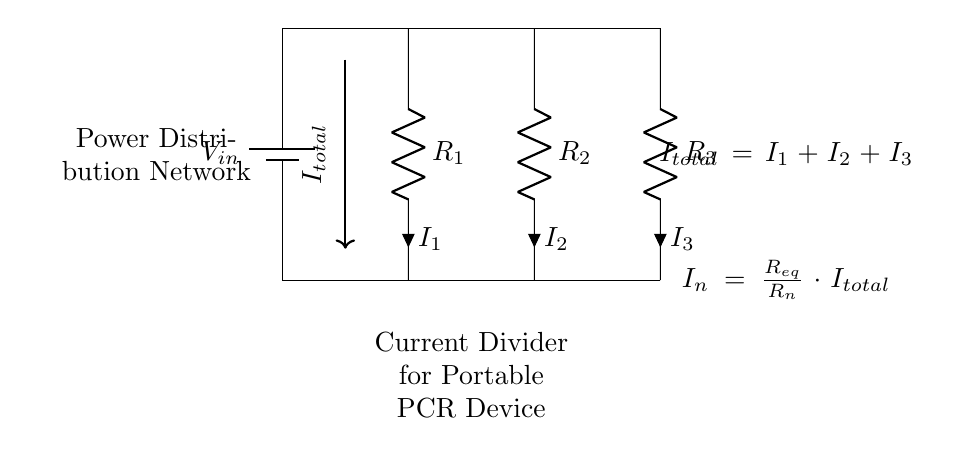What is the input voltage of this circuit? The input voltage, indicated by the label V_in, is the voltage source connected at the top of the circuit. While the specific value is not provided in the diagram, it is represented as V_in.
Answer: V_in What are the resistors in the circuit? The resistors in the circuit are labeled as R_1, R_2, and R_3, which are connected in parallel. These can be identified by the component symbols and their labels directly placed in the diagram.
Answer: R_1, R_2, R_3 How is the total current defined in this circuit? The total current is defined at the input as I_total, which is the sum of the currents I_1, I_2, and I_3 flowing through the individual resistors. This is shown in the diagram as I_total = I_1 + I_2 + I_3.
Answer: I_total = I_1 + I_2 + I_3 What does I_n represent in the current division formula? The label I_n represents the current flowing through a specific resistor, which can be calculated using the formula provided: I_n = (R_eq/R_n) * I_total. This indicates how the total current is divided among the resistors based on their resistance values.
Answer: The current through a specific resistor What is the equivalent resistance formula used in this circuit? The equivalent resistance formula is implied in the current division formula: R_eq. This value would be calculated based on the resistances of the individual resistors in parallel. The relationship is critical for determining current distribution in a parallel resistive network.
Answer: R_eq involved in calculations Which type of network is used for power distribution in this circuit? The power distribution method used in this circuit is a parallel current divider network. This is indicated in the diagram by the arrangement of resistors connected in parallel, which divides the current among them.
Answer: Parallel current divider network 